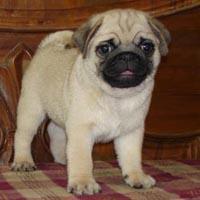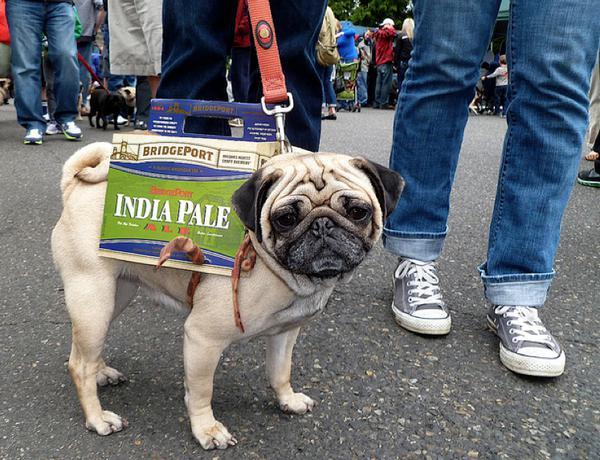The first image is the image on the left, the second image is the image on the right. For the images displayed, is the sentence "The left image contains a row of three pugs, and the right image shows one pug lying flat." factually correct? Answer yes or no. No. The first image is the image on the left, the second image is the image on the right. Considering the images on both sides, is "There are exactly four dogs in total." valid? Answer yes or no. No. 